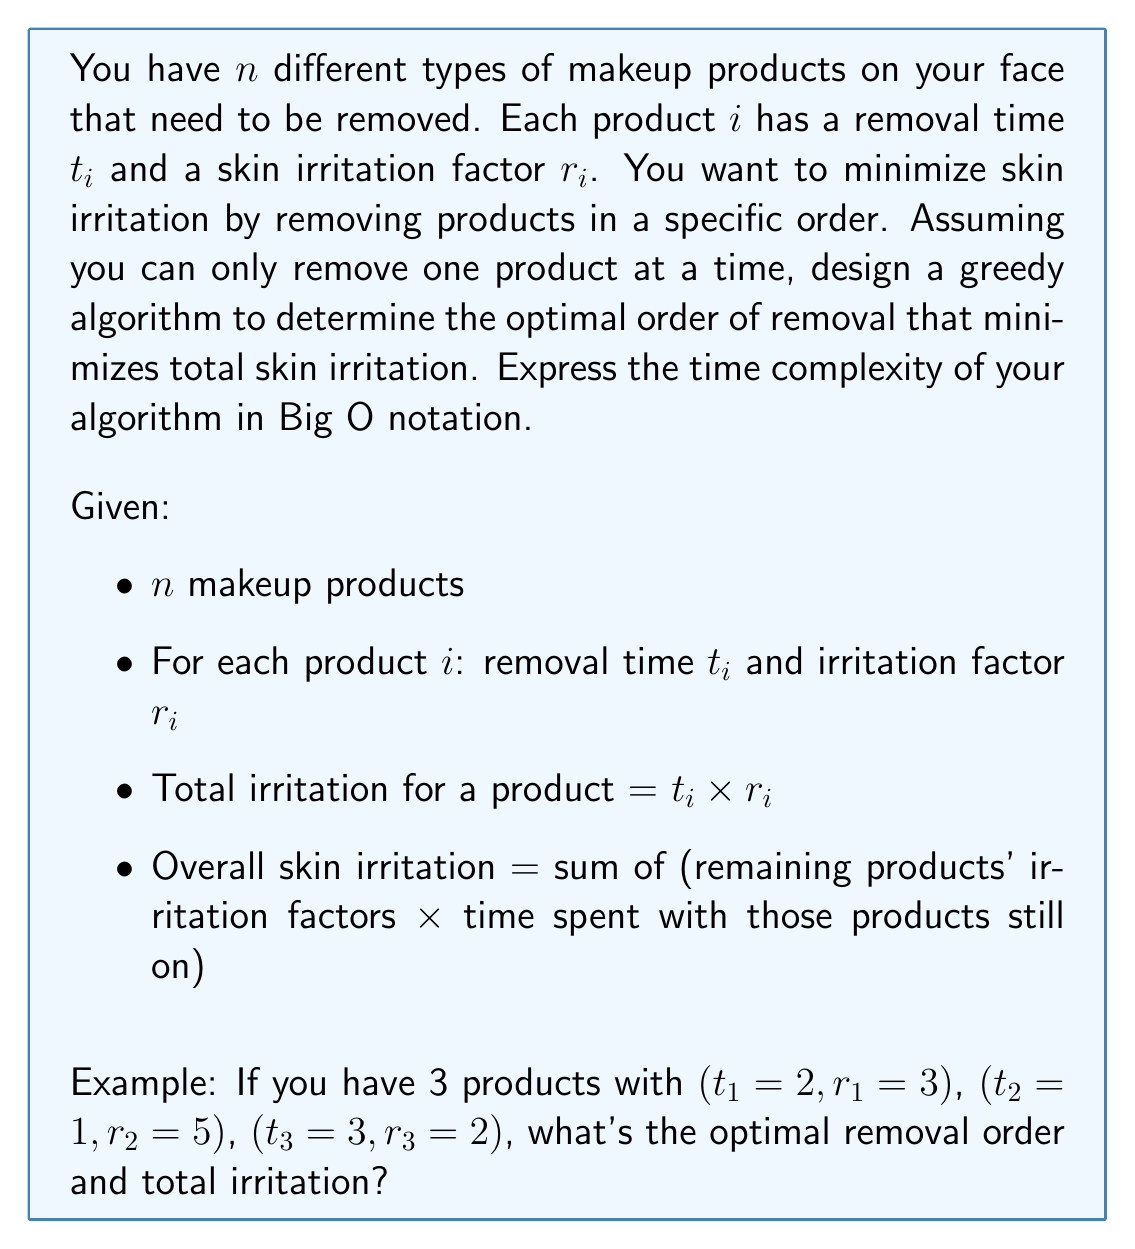Show me your answer to this math problem. To solve this problem using a greedy algorithm, we can follow these steps:

1) First, we need to understand what contributes most to the overall skin irritation. Products with high irritation factors that remain on the skin for a long time will cause the most irritation.

2) The key observation is that we should remove products with high irritation factors first to minimize their impact on the overall irritation.

3) We can calculate a "priority score" for each product: $p_i = r_i / t_i$. This score represents how much irritation the product causes per unit of removal time.

4) The greedy algorithm will be:
   a) Calculate the priority score $p_i = r_i / t_i$ for each product.
   b) Sort the products in descending order of their priority scores.
   c) Remove the products in this sorted order.

5) For the example given:
   Product 1: $p_1 = 3/2 = 1.5$
   Product 2: $p_2 = 5/1 = 5$
   Product 3: $p_3 = 2/3 \approx 0.67$

6) The sorted order is: Product 2, Product 1, Product 3

7) Calculating the total irritation:
   - Remove Product 2: $1 \times (3 + 2) = 5$
   - Remove Product 1: $2 \times 2 = 4$
   - Remove Product 3: $3 \times 0 = 0$
   Total irritation = $5 + 4 + 0 = 9$

Time Complexity Analysis:
- Calculating priority scores: $O(n)$
- Sorting products: $O(n \log n)$
- Removing products in order: $O(n)$

The overall time complexity is dominated by the sorting step: $O(n \log n)$
Answer: The optimal removal order is: Product 2, Product 1, Product 3
The total irritation is 9
The time complexity of the algorithm is $O(n \log n)$ 